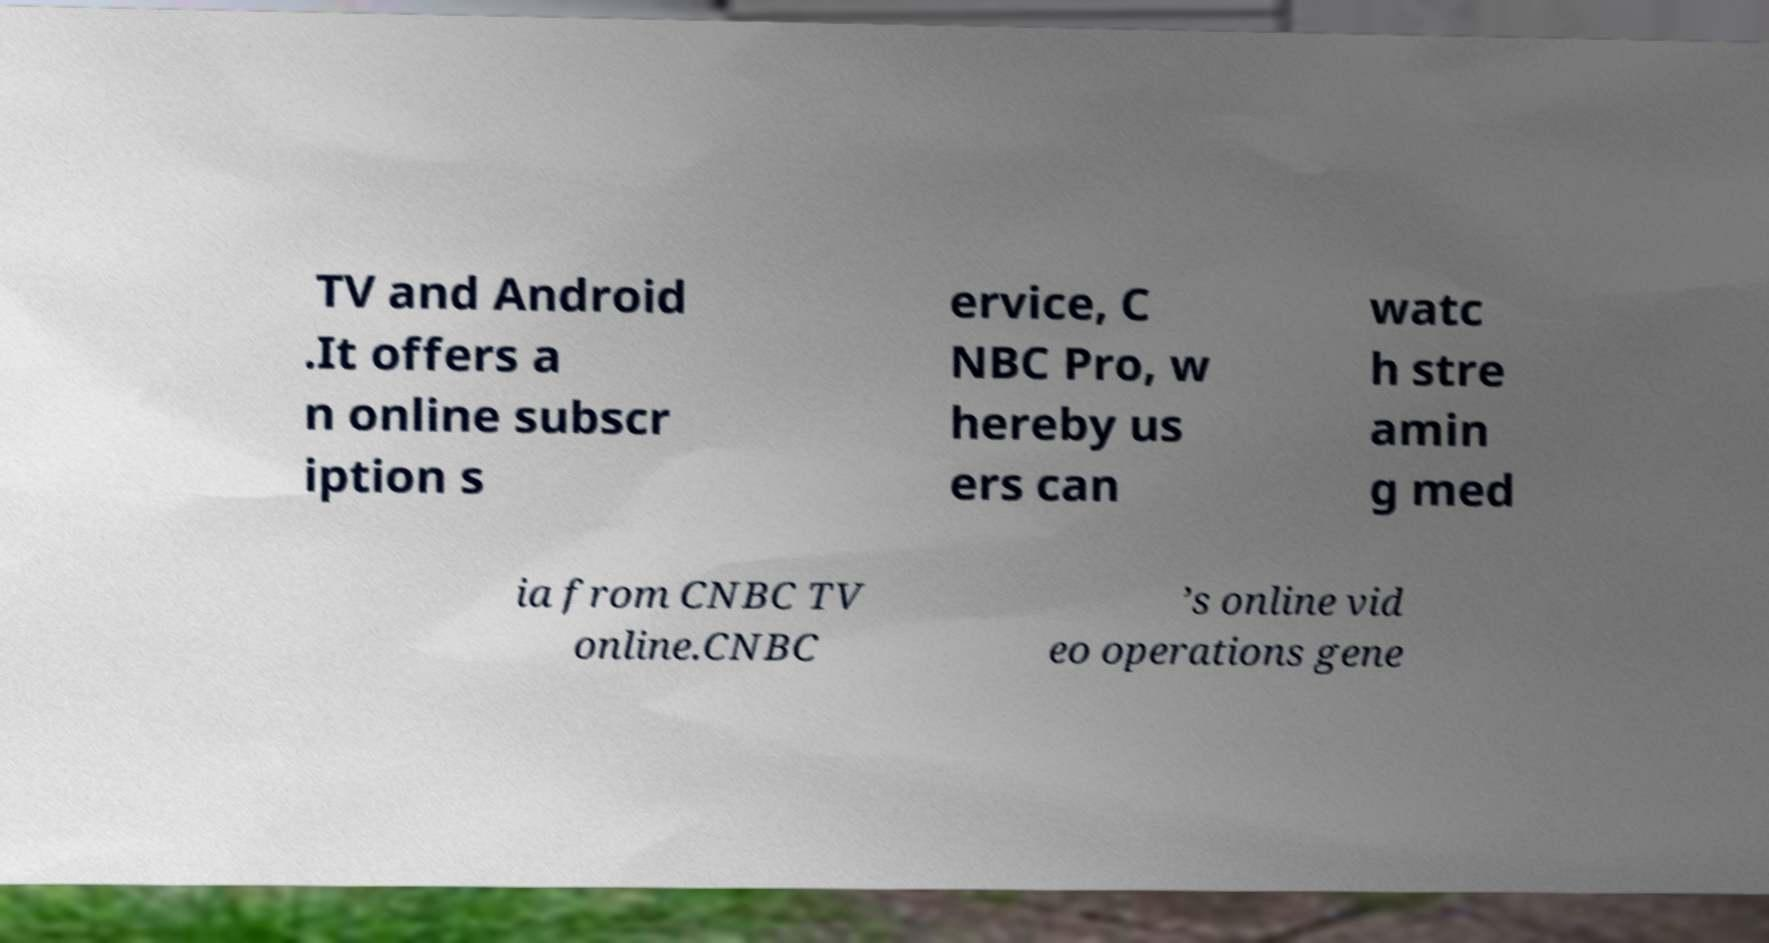Could you extract and type out the text from this image? TV and Android .It offers a n online subscr iption s ervice, C NBC Pro, w hereby us ers can watc h stre amin g med ia from CNBC TV online.CNBC ’s online vid eo operations gene 